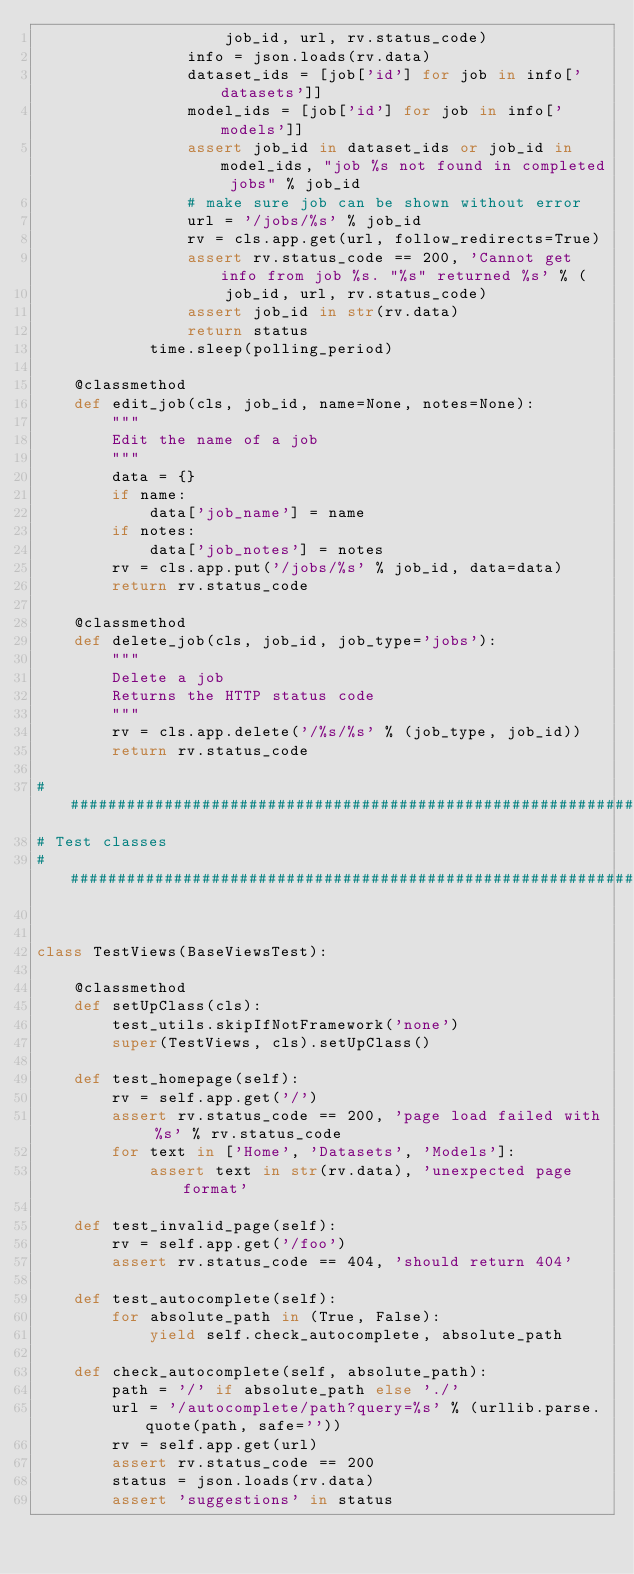Convert code to text. <code><loc_0><loc_0><loc_500><loc_500><_Python_>                    job_id, url, rv.status_code)
                info = json.loads(rv.data)
                dataset_ids = [job['id'] for job in info['datasets']]
                model_ids = [job['id'] for job in info['models']]
                assert job_id in dataset_ids or job_id in model_ids, "job %s not found in completed jobs" % job_id
                # make sure job can be shown without error
                url = '/jobs/%s' % job_id
                rv = cls.app.get(url, follow_redirects=True)
                assert rv.status_code == 200, 'Cannot get info from job %s. "%s" returned %s' % (
                    job_id, url, rv.status_code)
                assert job_id in str(rv.data)
                return status
            time.sleep(polling_period)

    @classmethod
    def edit_job(cls, job_id, name=None, notes=None):
        """
        Edit the name of a job
        """
        data = {}
        if name:
            data['job_name'] = name
        if notes:
            data['job_notes'] = notes
        rv = cls.app.put('/jobs/%s' % job_id, data=data)
        return rv.status_code

    @classmethod
    def delete_job(cls, job_id, job_type='jobs'):
        """
        Delete a job
        Returns the HTTP status code
        """
        rv = cls.app.delete('/%s/%s' % (job_type, job_id))
        return rv.status_code

################################################################################
# Test classes
################################################################################


class TestViews(BaseViewsTest):

    @classmethod
    def setUpClass(cls):
        test_utils.skipIfNotFramework('none')
        super(TestViews, cls).setUpClass()

    def test_homepage(self):
        rv = self.app.get('/')
        assert rv.status_code == 200, 'page load failed with %s' % rv.status_code
        for text in ['Home', 'Datasets', 'Models']:
            assert text in str(rv.data), 'unexpected page format'

    def test_invalid_page(self):
        rv = self.app.get('/foo')
        assert rv.status_code == 404, 'should return 404'

    def test_autocomplete(self):
        for absolute_path in (True, False):
            yield self.check_autocomplete, absolute_path

    def check_autocomplete(self, absolute_path):
        path = '/' if absolute_path else './'
        url = '/autocomplete/path?query=%s' % (urllib.parse.quote(path, safe=''))
        rv = self.app.get(url)
        assert rv.status_code == 200
        status = json.loads(rv.data)
        assert 'suggestions' in status
</code> 